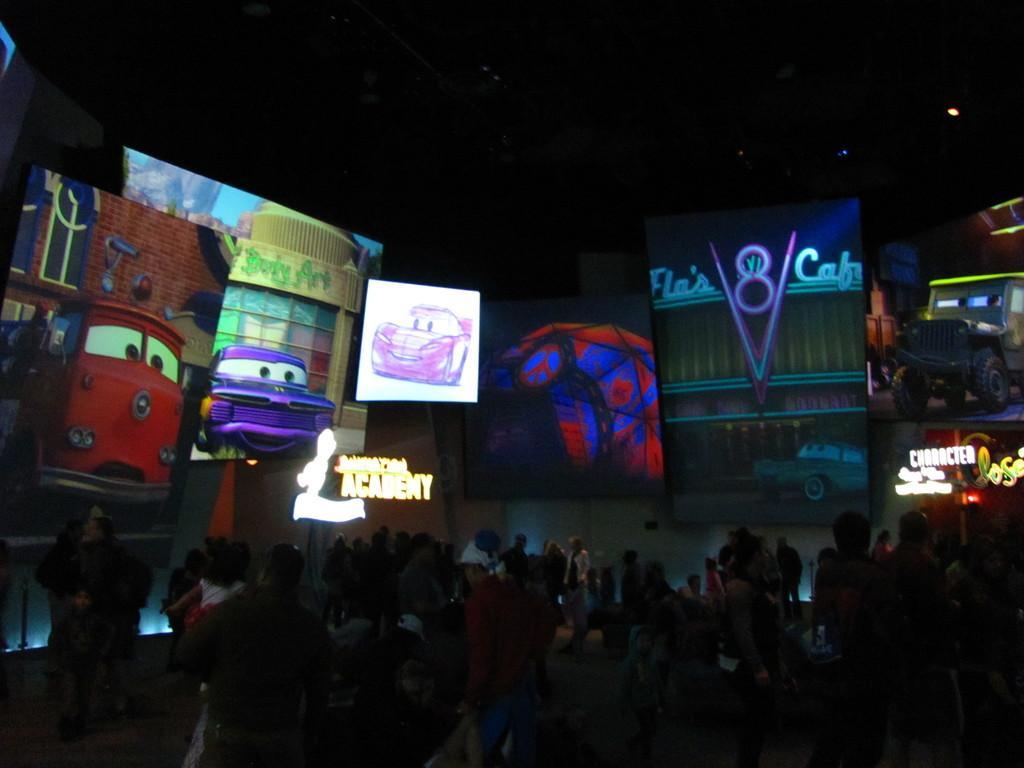Can you describe this image briefly? In this image I can see number of persons are standing on the ground and I can see number of boards and a screen in which I can see few cars which are red, violet and green in color. I can see few lights and the dark sky in the background. 